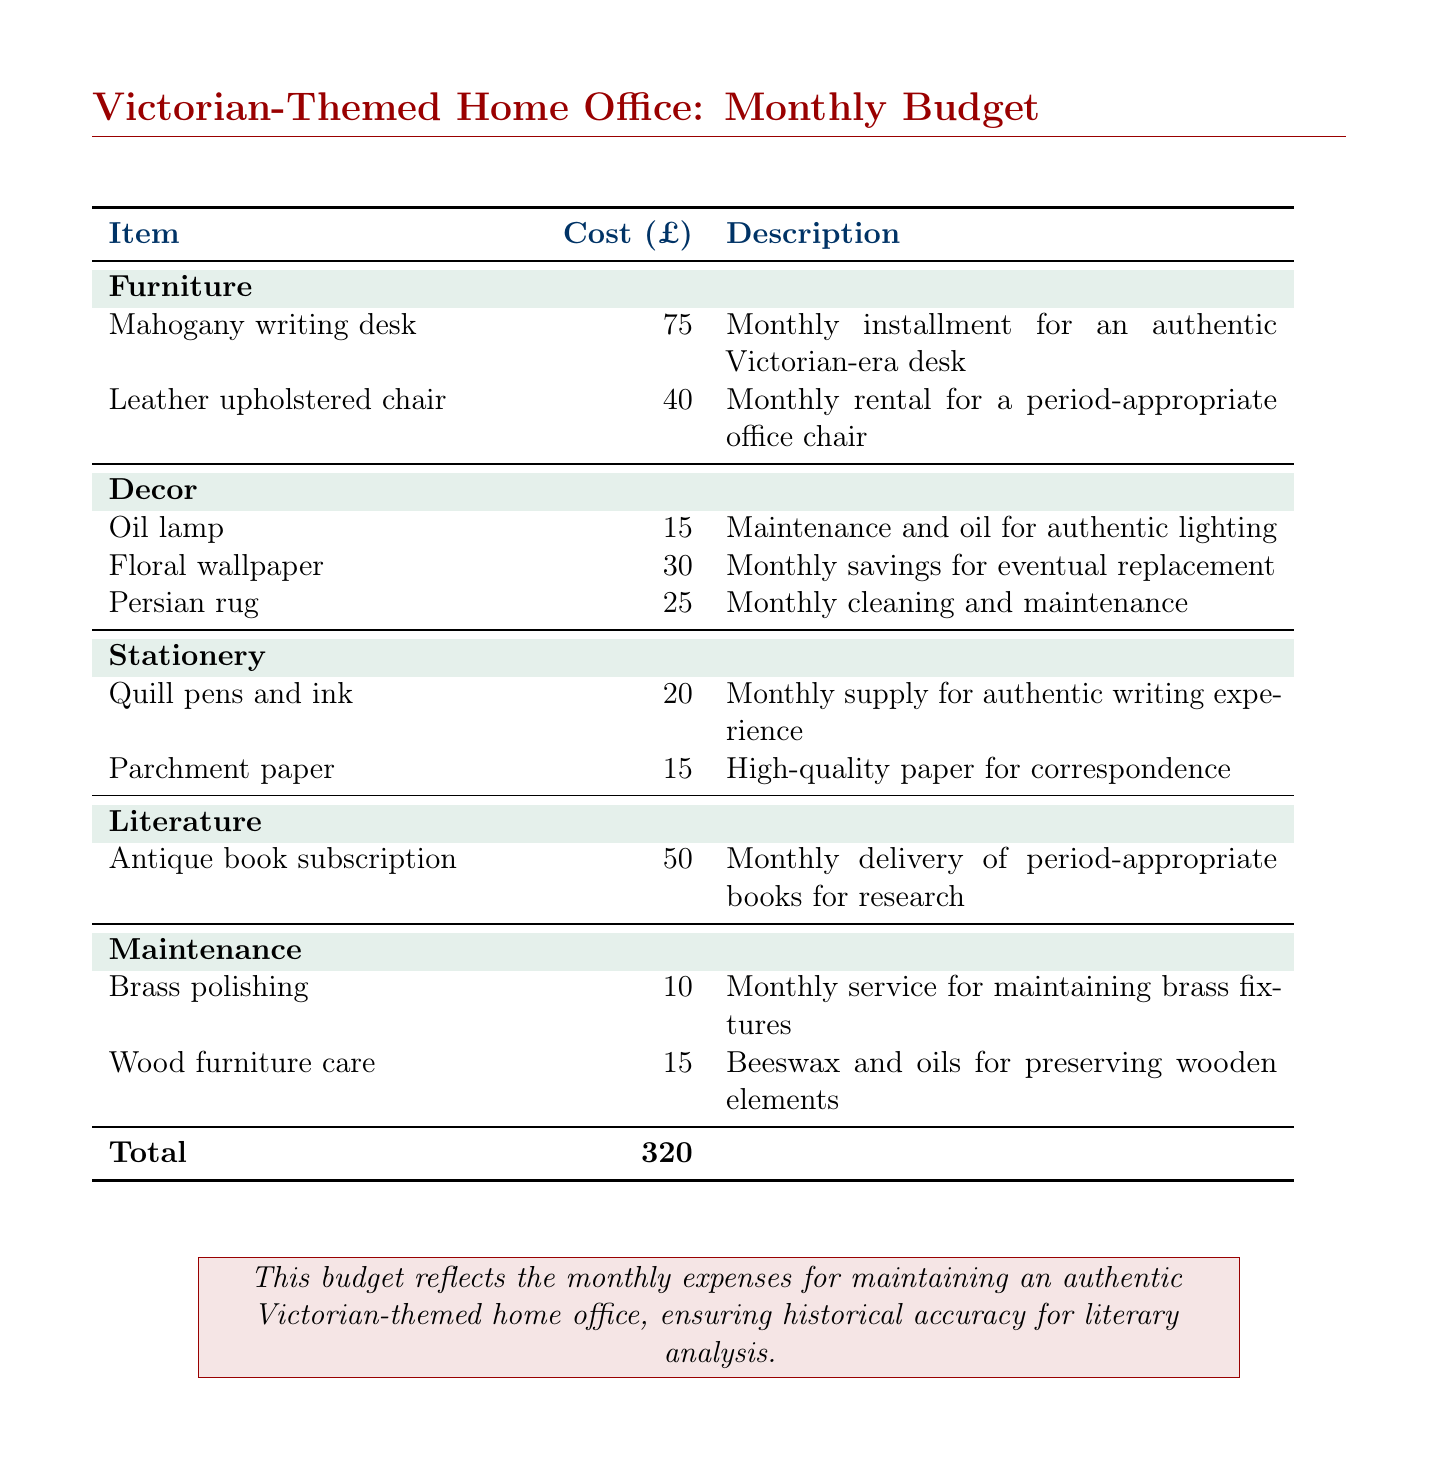What is the total monthly cost? The total monthly cost is provided in the document summary, calculated from the individual expenses listed.
Answer: 320 How much is the monthly installment for the mahogany writing desk? The document specifies the monthly installment cost for the mahogany writing desk under the furniture section.
Answer: 75 What is included in the monthly maintenance for the brass polishing? The maintenance item for brass polishing is listed separately with its cost in the document.
Answer: 10 How much is saved monthly for the floral wallpaper replacement? The monthly savings for the eventual replacement of floral wallpaper is directly stated in the document.
Answer: 30 What type of chair is rented monthly? The document describes the type of office chair being rented for the Victorian-themed office.
Answer: Leather upholstered chair What is the cost of the antique book subscription? The document lists the monthly cost for receiving period-appropriate books.
Answer: 50 How much is allocated monthly for quill pens and ink? The document specifies the expense for quill pens and ink in the stationery section.
Answer: 20 What service is provided for wood furniture care? The document offers details about the maintenance service specifically mentioned for wood furniture.
Answer: Beeswax and oils How much is spent on cleaning and maintaining the Persian rug? The maintenance cost for the Persian rug is included in the decor section of the document.
Answer: 25 